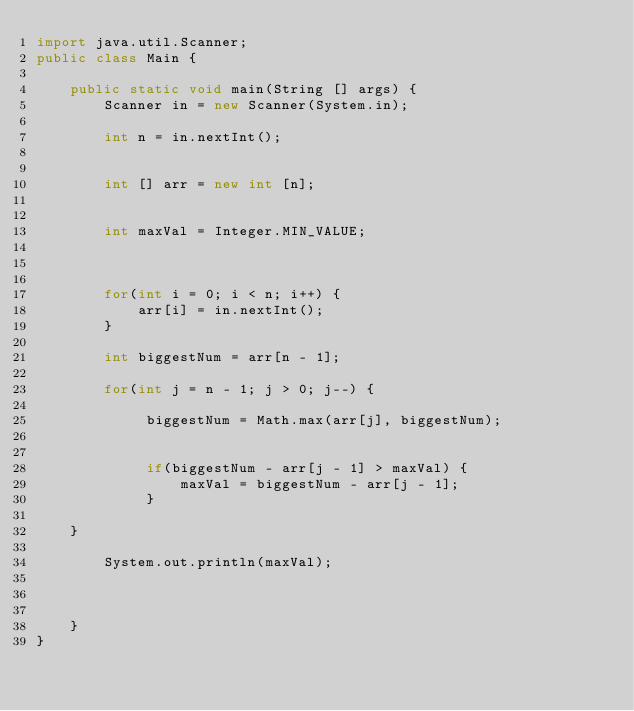Convert code to text. <code><loc_0><loc_0><loc_500><loc_500><_Java_>import java.util.Scanner;
public class Main {
	
	public static void main(String [] args) {
		Scanner in = new Scanner(System.in);
		
		int n = in.nextInt();
		
		
		int [] arr = new int [n];
		
		
		int maxVal = Integer.MIN_VALUE;
		
		
		
		for(int i = 0; i < n; i++) {
			arr[i] = in.nextInt();
		}
		
		int biggestNum = arr[n - 1];
		
		for(int j = n - 1; j > 0; j--) {
			
			 biggestNum = Math.max(arr[j], biggestNum);
			
			 
			 if(biggestNum - arr[j - 1] > maxVal) {
				 maxVal = biggestNum - arr[j - 1];
			 }
			 	
	}
		
		System.out.println(maxVal);
		
		

	}
}

</code> 